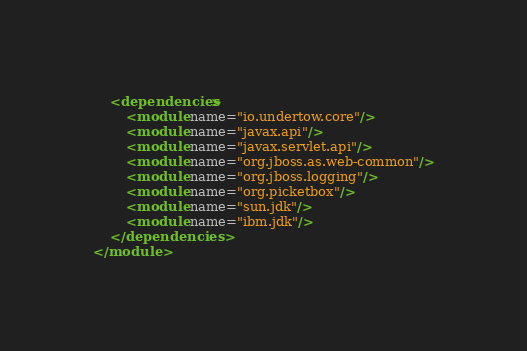<code> <loc_0><loc_0><loc_500><loc_500><_XML_>
    <dependencies>
        <module name="io.undertow.core"/>
        <module name="javax.api"/>
        <module name="javax.servlet.api"/>
        <module name="org.jboss.as.web-common"/>
        <module name="org.jboss.logging"/>
        <module name="org.picketbox"/>
        <module name="sun.jdk"/>
        <module name="ibm.jdk"/>
    </dependencies>
</module>
</code> 